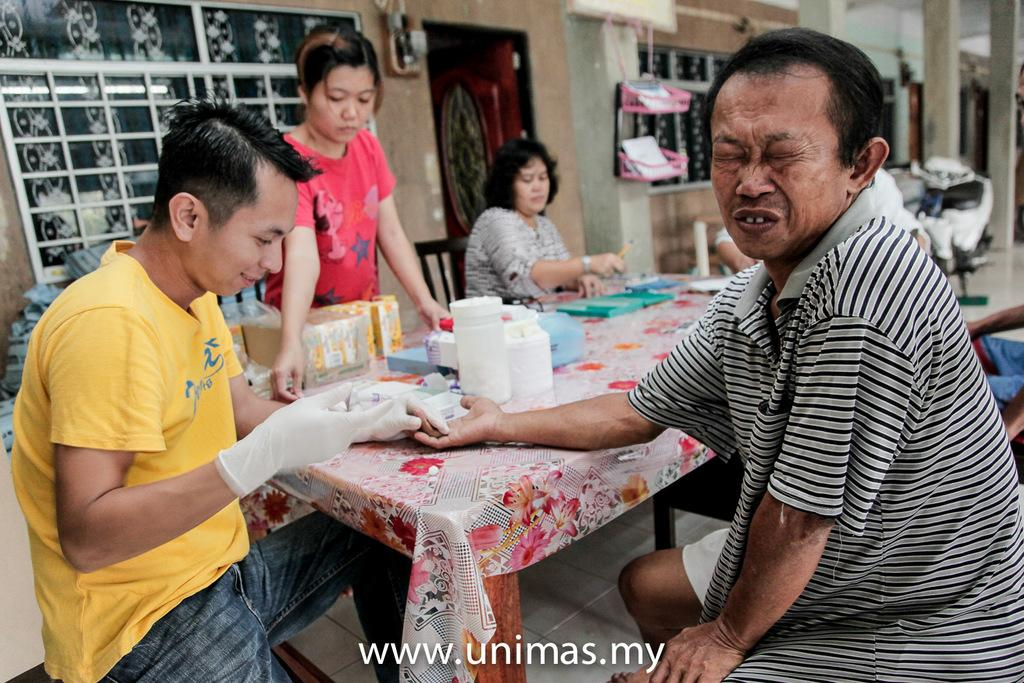How many people are sitting in the image? There are four persons sitting on chairs in the image. What is the main piece of furniture in the image? There is a table in the image. What items can be seen on the table? There are bottles, a cardboard box, and paper on the table. How are the bottles arranged on the table? There are bottles in a tray on the table. Is there a clock on the table in the image? There is no clock visible on the table in the image. Are any of the persons in the image spying on the others? There is no indication of spying or any suspicious behavior among the persons in the image. 